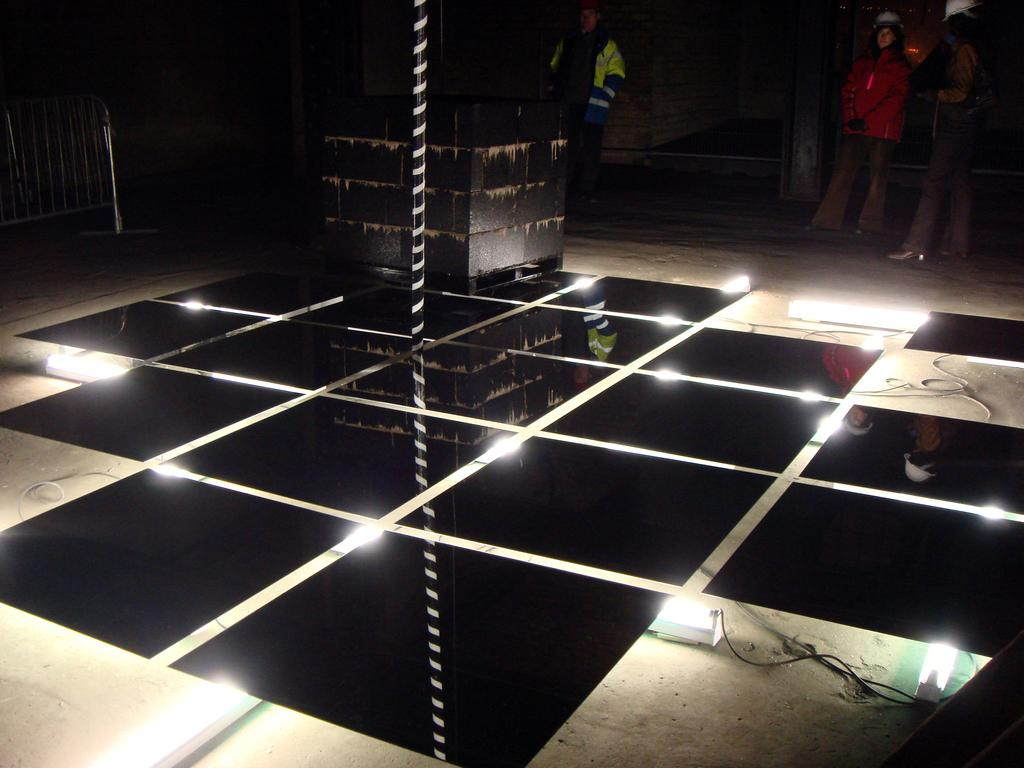What can be seen in the image that provides illumination? There are lights in the image. What are the three people doing in the image? The three people are standing on electrical wires. What is located next to the electrical wires? There is an iron grill next to the wires. What type of surface can be seen in the image for dancing? There is a dance floor in the image. What colors are used for the dance floor? The dance floor is white and black in color. What type of pie is being served on the dance floor in the image? There is no pie present in the image; it features a dance floor and people standing on electrical wires. What time of day is it in the image, and are the people joining together for an afternoon activity? The time of day is not mentioned in the image, and there is no indication of a specific activity like joining together for an afternoon event. 